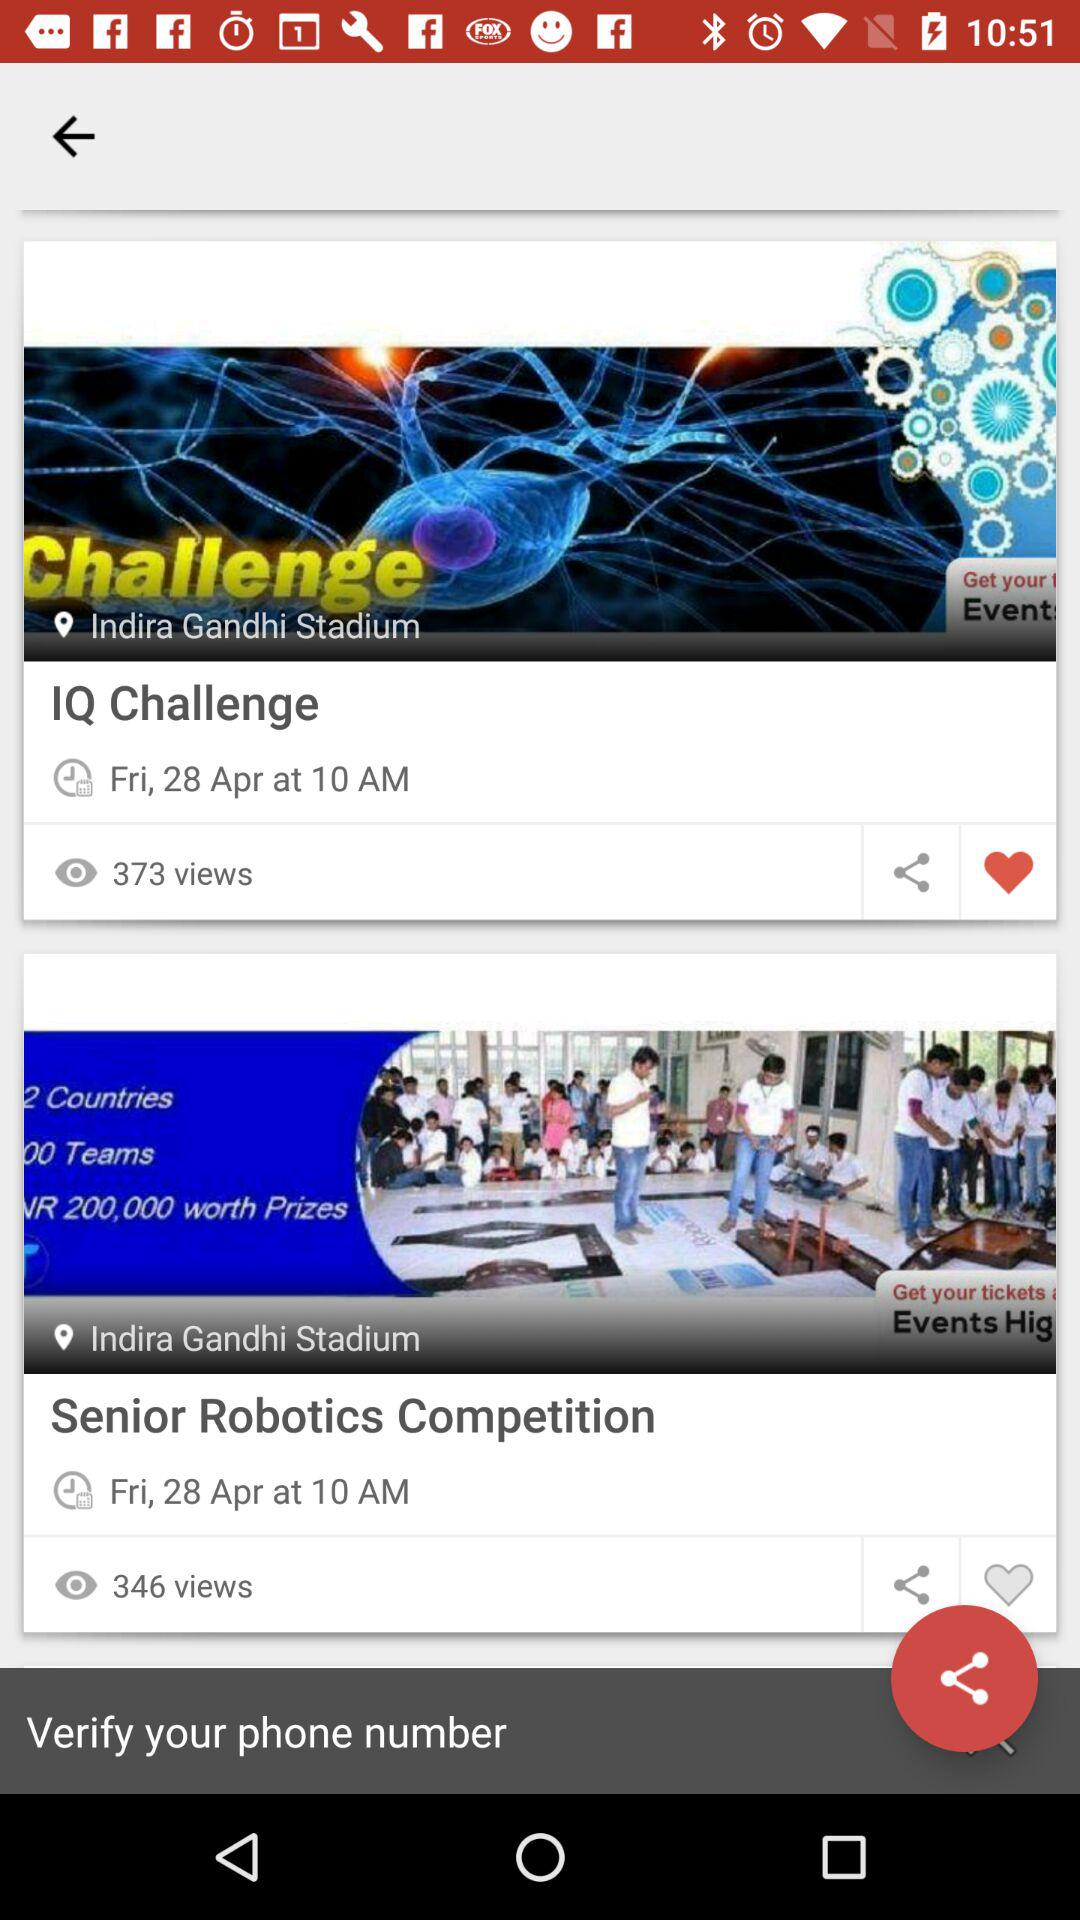What is the location of the events? The location is Indira Gandhi Stadium. 